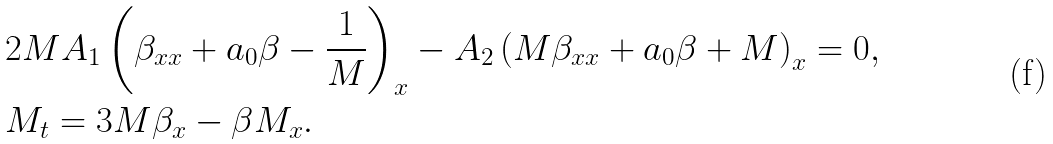Convert formula to latex. <formula><loc_0><loc_0><loc_500><loc_500>& 2 M A _ { 1 } \left ( \beta _ { x x } + a _ { 0 } \beta - \frac { 1 } { M } \right ) _ { x } - A _ { 2 } \left ( M \beta _ { x x } + a _ { 0 } \beta + M \right ) _ { x } = 0 , \\ & M _ { t } = 3 M \beta _ { x } - \beta M _ { x } .</formula> 